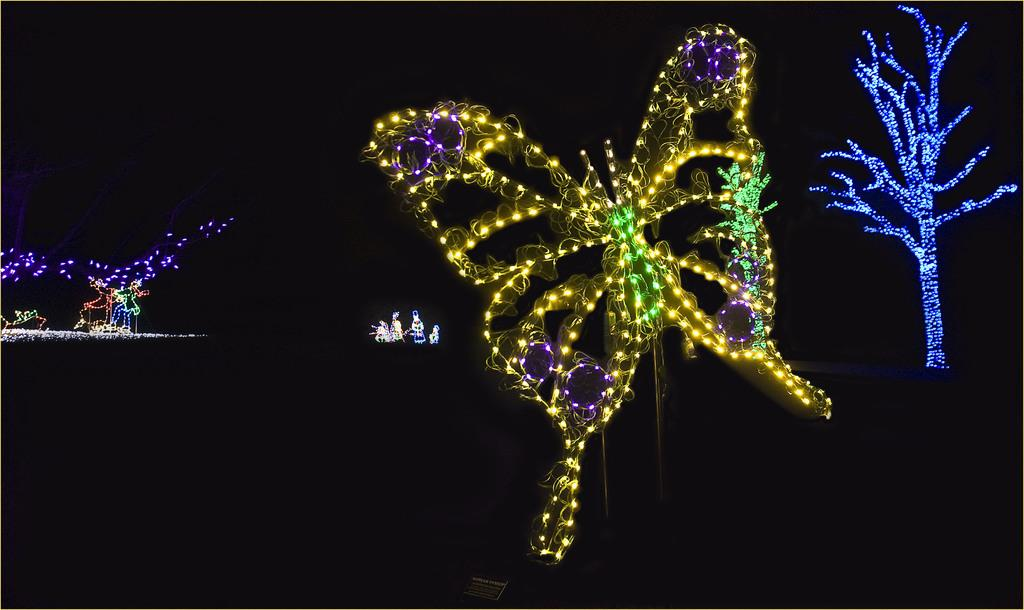What shape is formed by the arrangement of lights in the image? The lights are arranged in the shape of a butterfly in the image. Where are the majority of the lights located? The lights are located on the left side of the image and attached to a tree on the right side of the image. What is the color of the background in the image? The background of the image is black. How many eyes does the goose have in the image? There is no goose present in the image, so it is not possible to determine the number of eyes it might have. 